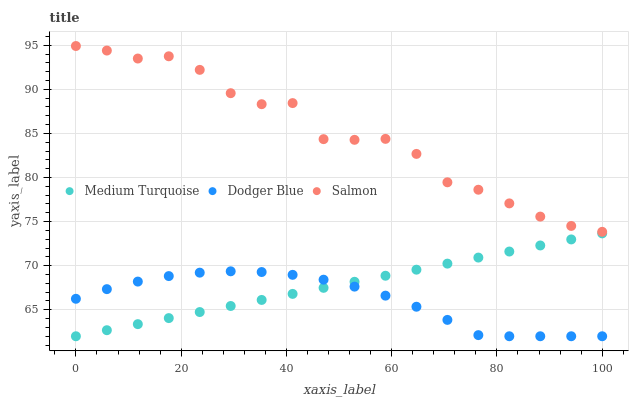Does Dodger Blue have the minimum area under the curve?
Answer yes or no. Yes. Does Salmon have the maximum area under the curve?
Answer yes or no. Yes. Does Medium Turquoise have the minimum area under the curve?
Answer yes or no. No. Does Medium Turquoise have the maximum area under the curve?
Answer yes or no. No. Is Medium Turquoise the smoothest?
Answer yes or no. Yes. Is Salmon the roughest?
Answer yes or no. Yes. Is Dodger Blue the smoothest?
Answer yes or no. No. Is Dodger Blue the roughest?
Answer yes or no. No. Does Dodger Blue have the lowest value?
Answer yes or no. Yes. Does Salmon have the highest value?
Answer yes or no. Yes. Does Medium Turquoise have the highest value?
Answer yes or no. No. Is Dodger Blue less than Salmon?
Answer yes or no. Yes. Is Salmon greater than Dodger Blue?
Answer yes or no. Yes. Does Medium Turquoise intersect Dodger Blue?
Answer yes or no. Yes. Is Medium Turquoise less than Dodger Blue?
Answer yes or no. No. Is Medium Turquoise greater than Dodger Blue?
Answer yes or no. No. Does Dodger Blue intersect Salmon?
Answer yes or no. No. 